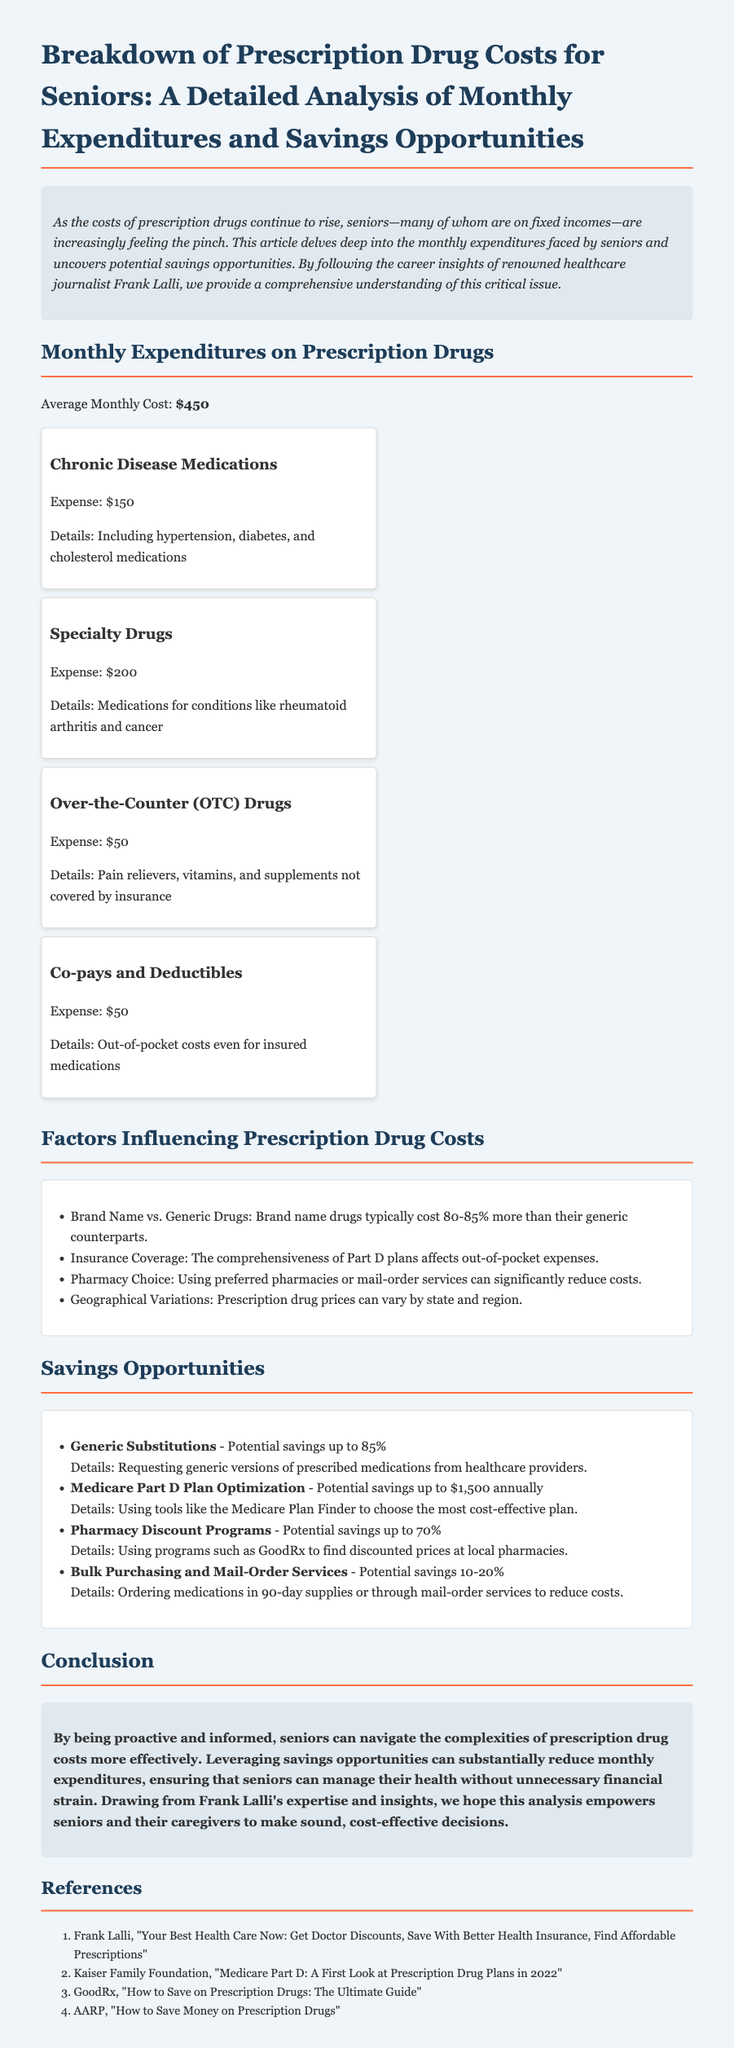what is the average monthly cost of prescription drugs for seniors? The average monthly cost mentioned in the document is highlighted clearly as $450.
Answer: $450 how much do chronic disease medications cost monthly? The document states the monthly expense for chronic disease medications is specified, which is $150.
Answer: $150 what potential savings can be achieved through generic substitutions? The document lists potential savings by substituting generic medications, which are stated as up to 85%.
Answer: up to 85% which factor can lead to higher prescription drug costs? The document mentions factors like brand name drugs costing significantly more than their generic counterparts.
Answer: Brand Name vs. Generic Drugs what is a significant savings opportunity related to Medicare? The analysis outlines Medicare Part D plan optimization as a way to save money, potentially up to $1,500 annually.
Answer: up to $1,500 annually what is the total monthly expenditure on over-the-counter drugs for seniors? The document specifically mentions that the monthly expense for over-the-counter drugs is $50.
Answer: $50 which source provides further insights on prescription drugs? The references section lists Frank Lalli's work as a source for more insights.
Answer: Frank Lalli what can seniors do to potentially reduce costs by using mail-order services? The document recommends bulk purchasing and mail-order services as a savings strategy, with potential savings noted.
Answer: 10-20% what are the co-pays and deductibles expense? The document clearly states that co-pays and deductibles result in an out-of-pocket expense of $50.
Answer: $50 